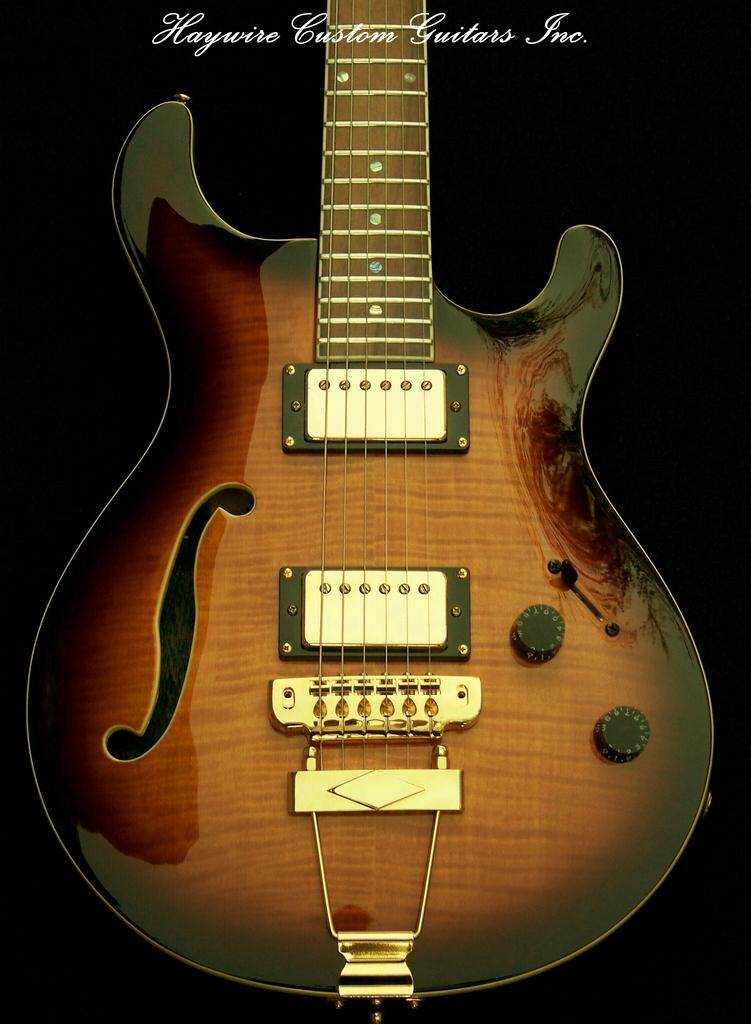What musical instrument is present in the picture? There is a guitar in the picture. What is the color of the guitar? The guitar is brown in color. Are there any additional design elements on the guitar? Yes, the guitar has a black border. How many strings does the guitar have? The guitar has six strings. Can you tell me how many dinosaurs are playing the guitar in the image? There are no dinosaurs present in the image, and therefore no dinosaurs are playing the guitar. What subject is being taught by the guitar in the image? The guitar is a musical instrument and not a teacher, so it is not teaching any subject in the image. 